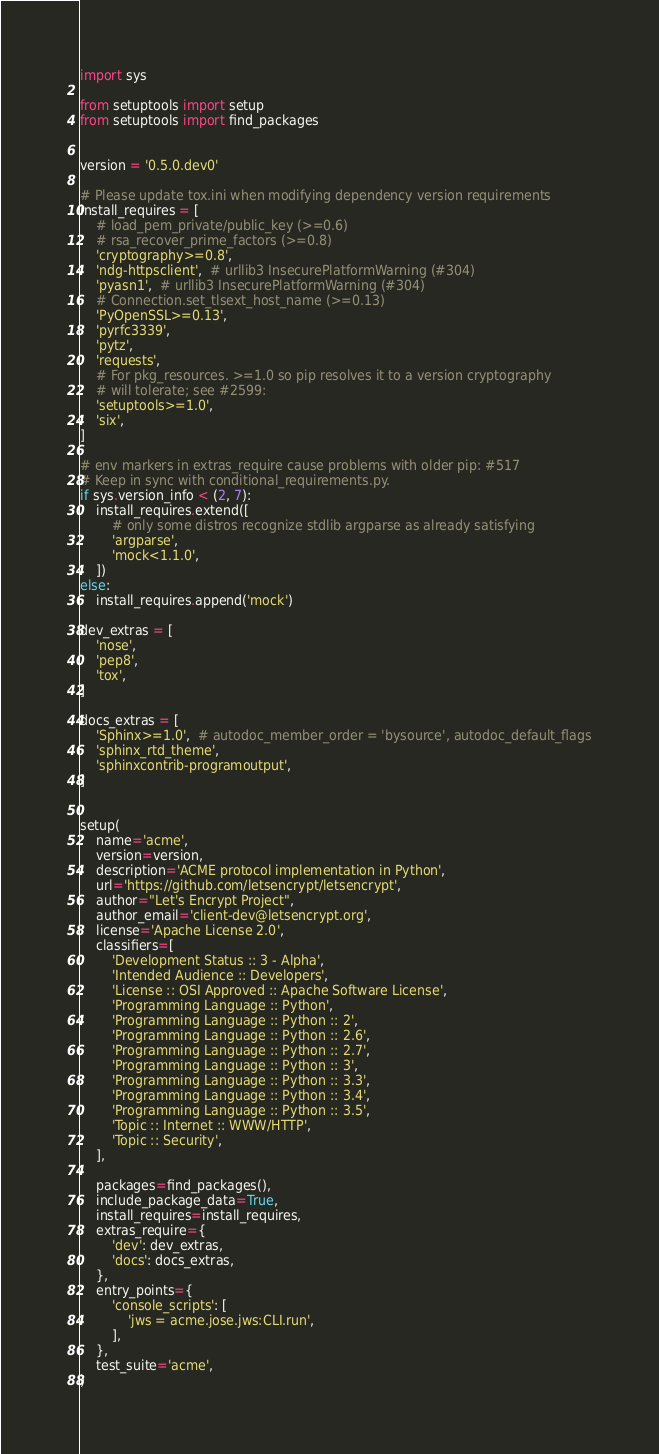Convert code to text. <code><loc_0><loc_0><loc_500><loc_500><_Python_>import sys

from setuptools import setup
from setuptools import find_packages


version = '0.5.0.dev0'

# Please update tox.ini when modifying dependency version requirements
install_requires = [
    # load_pem_private/public_key (>=0.6)
    # rsa_recover_prime_factors (>=0.8)
    'cryptography>=0.8',
    'ndg-httpsclient',  # urllib3 InsecurePlatformWarning (#304)
    'pyasn1',  # urllib3 InsecurePlatformWarning (#304)
    # Connection.set_tlsext_host_name (>=0.13)
    'PyOpenSSL>=0.13',
    'pyrfc3339',
    'pytz',
    'requests',
    # For pkg_resources. >=1.0 so pip resolves it to a version cryptography
    # will tolerate; see #2599:
    'setuptools>=1.0',
    'six',
]

# env markers in extras_require cause problems with older pip: #517
# Keep in sync with conditional_requirements.py.
if sys.version_info < (2, 7):
    install_requires.extend([
        # only some distros recognize stdlib argparse as already satisfying
        'argparse',
        'mock<1.1.0',
    ])
else:
    install_requires.append('mock')

dev_extras = [
    'nose',
    'pep8',
    'tox',
]

docs_extras = [
    'Sphinx>=1.0',  # autodoc_member_order = 'bysource', autodoc_default_flags
    'sphinx_rtd_theme',
    'sphinxcontrib-programoutput',
]


setup(
    name='acme',
    version=version,
    description='ACME protocol implementation in Python',
    url='https://github.com/letsencrypt/letsencrypt',
    author="Let's Encrypt Project",
    author_email='client-dev@letsencrypt.org',
    license='Apache License 2.0',
    classifiers=[
        'Development Status :: 3 - Alpha',
        'Intended Audience :: Developers',
        'License :: OSI Approved :: Apache Software License',
        'Programming Language :: Python',
        'Programming Language :: Python :: 2',
        'Programming Language :: Python :: 2.6',
        'Programming Language :: Python :: 2.7',
        'Programming Language :: Python :: 3',
        'Programming Language :: Python :: 3.3',
        'Programming Language :: Python :: 3.4',
        'Programming Language :: Python :: 3.5',
        'Topic :: Internet :: WWW/HTTP',
        'Topic :: Security',
    ],

    packages=find_packages(),
    include_package_data=True,
    install_requires=install_requires,
    extras_require={
        'dev': dev_extras,
        'docs': docs_extras,
    },
    entry_points={
        'console_scripts': [
            'jws = acme.jose.jws:CLI.run',
        ],
    },
    test_suite='acme',
)
</code> 